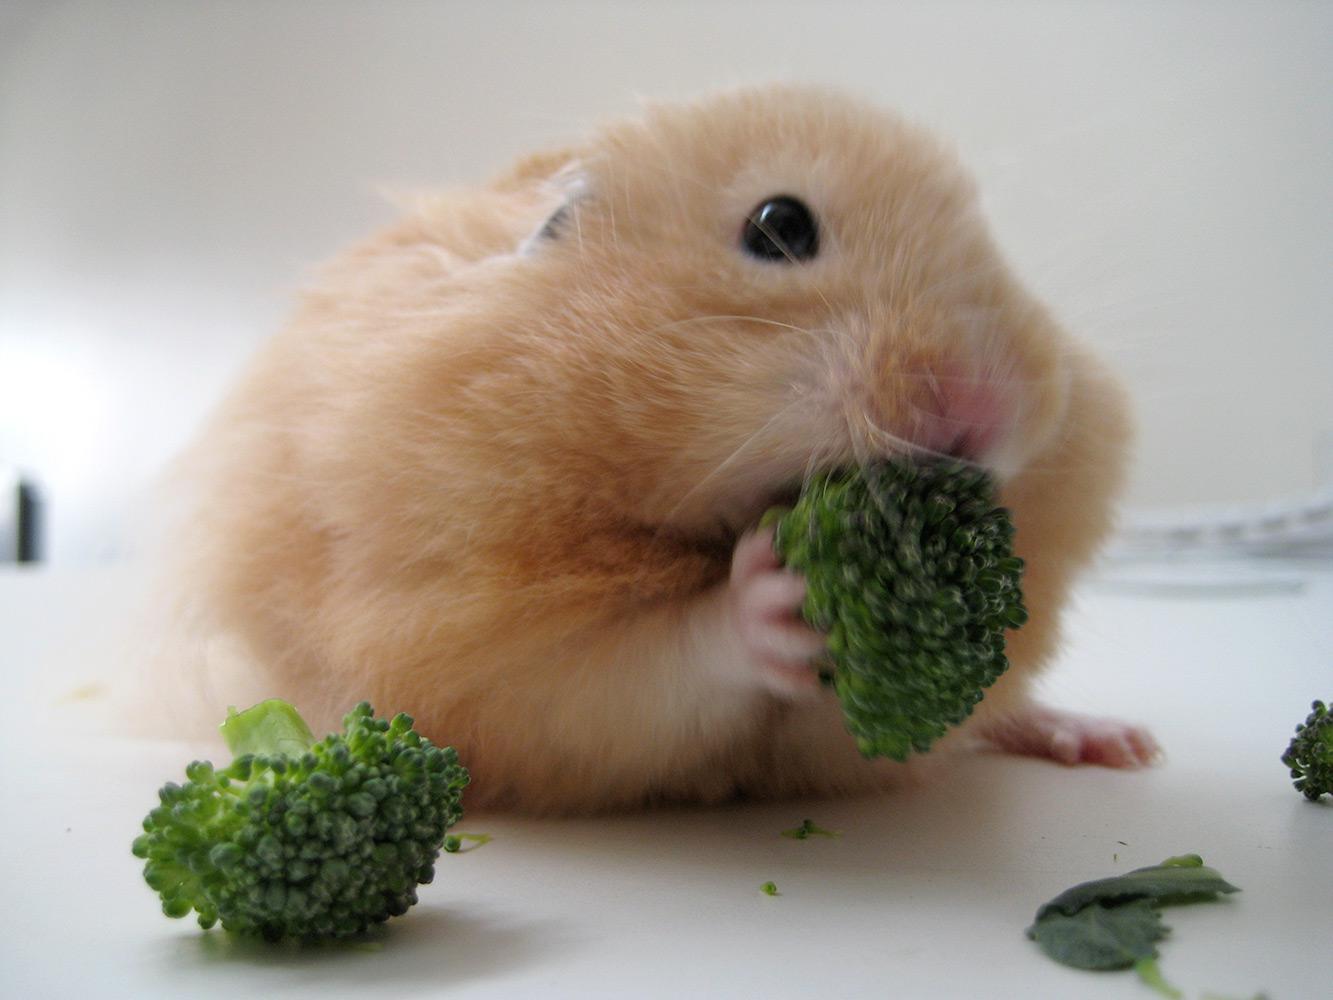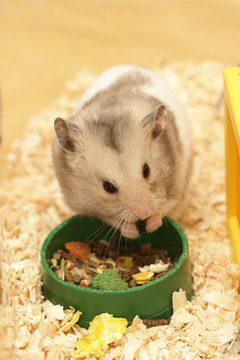The first image is the image on the left, the second image is the image on the right. Considering the images on both sides, is "There are two hamsters who are eating food." valid? Answer yes or no. Yes. The first image is the image on the left, the second image is the image on the right. Considering the images on both sides, is "The food in the left image is green in color." valid? Answer yes or no. Yes. 